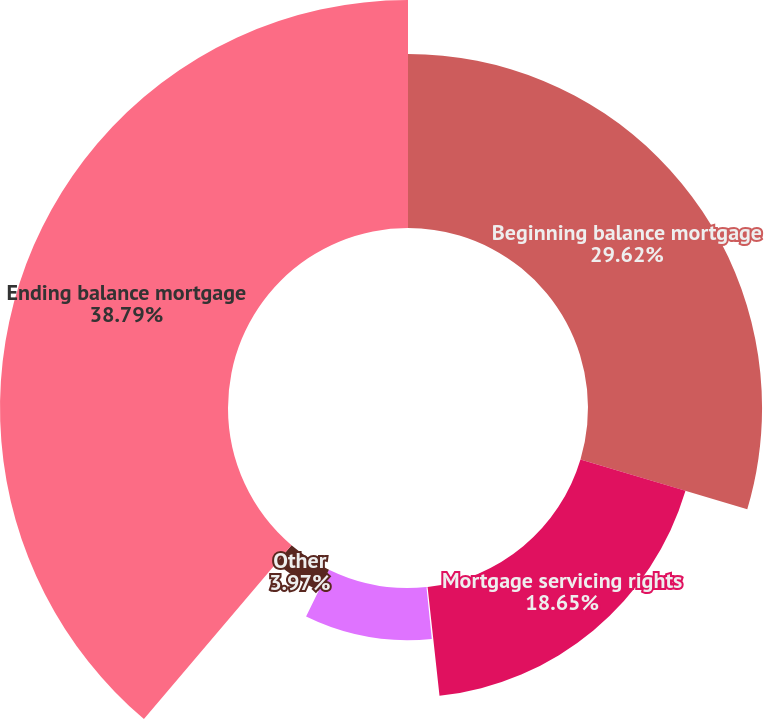Convert chart. <chart><loc_0><loc_0><loc_500><loc_500><pie_chart><fcel>Beginning balance mortgage<fcel>Mortgage servicing rights<fcel>Mortgage servicing rights sold<fcel>Amortization expense<fcel>Other<fcel>Ending balance mortgage<nl><fcel>29.62%<fcel>18.65%<fcel>0.1%<fcel>8.87%<fcel>3.97%<fcel>38.8%<nl></chart> 